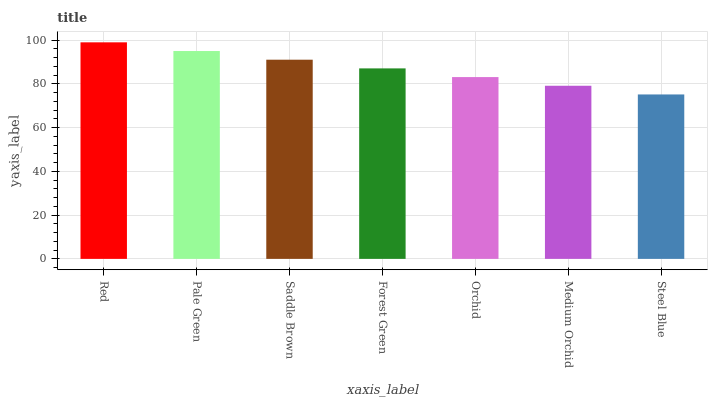Is Steel Blue the minimum?
Answer yes or no. Yes. Is Red the maximum?
Answer yes or no. Yes. Is Pale Green the minimum?
Answer yes or no. No. Is Pale Green the maximum?
Answer yes or no. No. Is Red greater than Pale Green?
Answer yes or no. Yes. Is Pale Green less than Red?
Answer yes or no. Yes. Is Pale Green greater than Red?
Answer yes or no. No. Is Red less than Pale Green?
Answer yes or no. No. Is Forest Green the high median?
Answer yes or no. Yes. Is Forest Green the low median?
Answer yes or no. Yes. Is Steel Blue the high median?
Answer yes or no. No. Is Saddle Brown the low median?
Answer yes or no. No. 